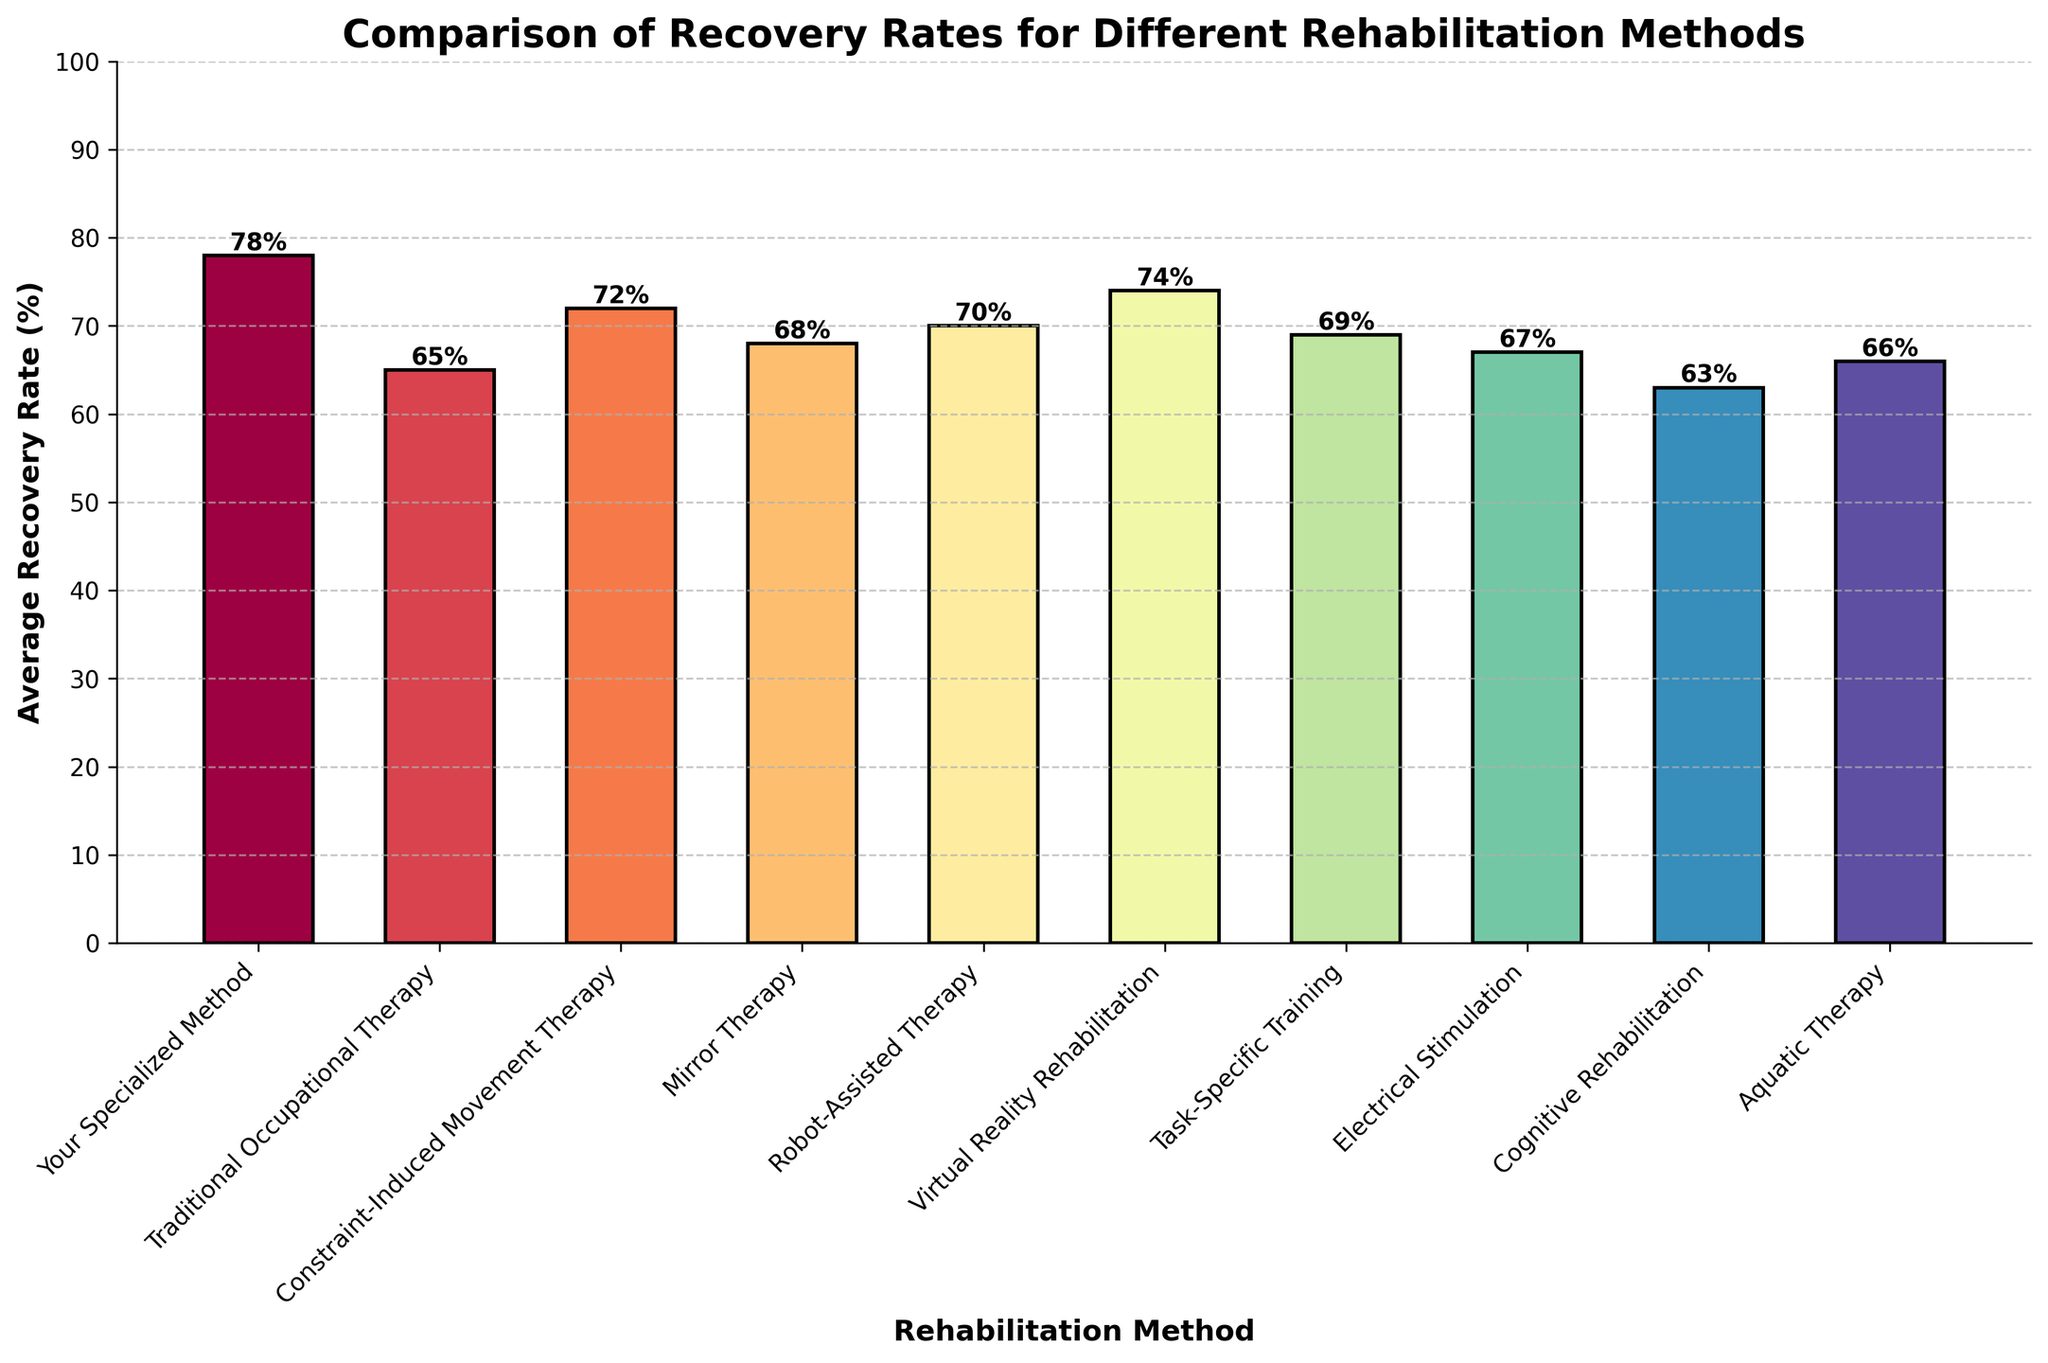Which rehabilitation method has the highest average recovery rate? By visually inspecting the heights of the bars, you can see that the tallest bar corresponds to 'Your Specialized Method' with an average recovery rate of 78%.
Answer: Your Specialized Method Which two methods have the closest average recovery rates? By comparing the bars, 'Task-Specific Training' and 'Mirror Therapy' have similar heights with recovery rates of 69% and 68%, respectively.
Answer: Task-Specific Training and Mirror Therapy What is the difference in average recovery rate between Robot-Assisted Therapy and Electrical Stimulation? The average recovery rate for Robot-Assisted Therapy is 70%, and for Electrical Stimulation, it is 67%. Subtracting these values gives 70% - 67% = 3%.
Answer: 3% Which method has a lower recovery rate, Virtual Reality Rehabilitation or Constraint-Induced Movement Therapy? By visually inspecting the heights of the bars, 'Constraint-Induced Movement Therapy' has a recovery rate of 72%, while 'Virtual Reality Rehabilitation' has a rate of 74%, making the former lower.
Answer: Constraint-Induced Movement Therapy What is the combined average recovery rate of the three lowest-performing methods? 'Cognitive Rehabilitation,' 'Traditional Occupational Therapy,' and 'Electrical Stimulation' have recovery rates of 63%, 65%, and 67%, respectively. Adding these gives 63 + 65 + 67 = 195. Divide by 3 to get the average: 195 / 3 = 65%.
Answer: 65% Which method shows the greatest improvement in recovery rate compared to Aquatic Therapy? 'Your Specialized Method' has a recovery rate of 78%, while 'Aquatic Therapy' has 66%. The improvement is 78% - 66% = 12%.
Answer: Your Specialized Method How many methods have a recovery rate above 70%? By visually inspecting the bars, the methods with recovery rates above 70% are 'Your Specialized Method,' 'Constraint-Induced Movement Therapy,' 'Virtual Reality Rehabilitation,' and 'Robot-Assisted Therapy.' There are 4 of them.
Answer: 4 What is the recovery rate range represented in the bar chart? The lowest recovery rate is 'Cognitive Rehabilitation' with 63%, and the highest is 'Your Specialized Method' with 78%. The range is 78% - 63% = 15%.
Answer: 15% Which method has a higher recovery rate, Aquatic Therapy or Cognitive Rehabilitation, and by how much? 'Aquatic Therapy' has a recovery rate of 66%, and 'Cognitive Rehabilitation' has 63%. The difference is 66% - 63% = 3%.
Answer: Aquatic Therapy by 3% Describe the color trend observed in the bars as we move from 'Cognitive Rehabilitation' to 'Your Specialized Method'. The bars shift from cooler colors like shades of blue and green towards warmer shades, culminating in red for 'Your Specialized Method.'
Answer: Cooler to Warmer 